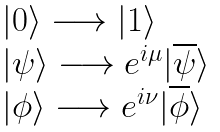Convert formula to latex. <formula><loc_0><loc_0><loc_500><loc_500>\begin{array} { l c l } & & | 0 \rangle \longrightarrow | 1 \rangle \\ & & | \psi \rangle \longrightarrow e ^ { i \mu } | \overline { \psi } \rangle \\ & & | \phi \rangle \longrightarrow e ^ { i \nu } | \overline { \phi } \rangle \end{array}</formula> 